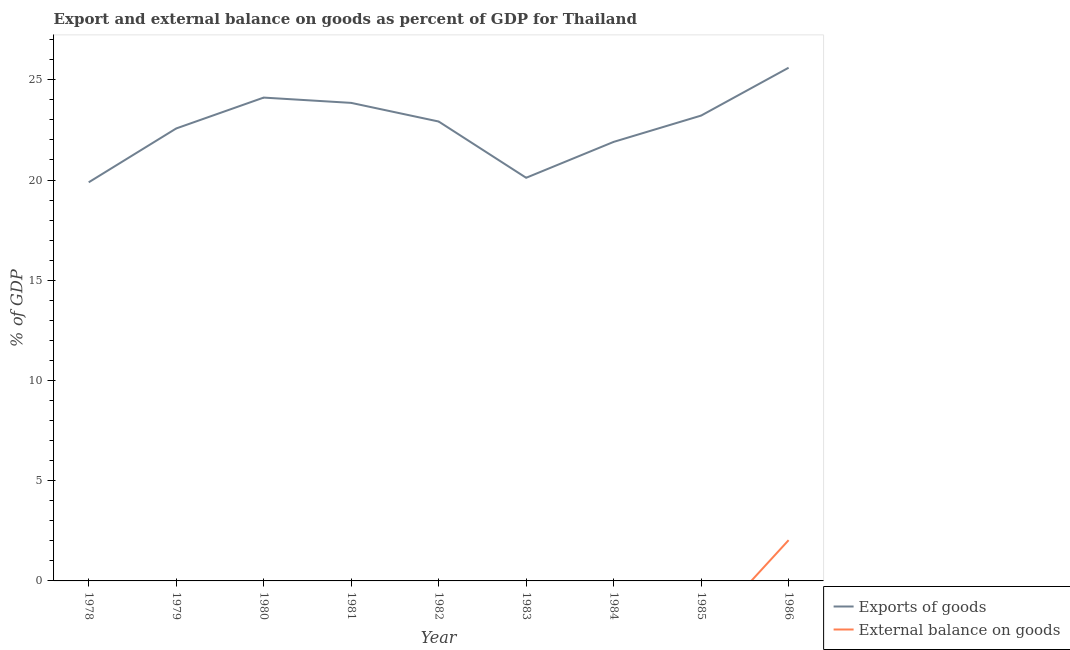How many different coloured lines are there?
Provide a succinct answer. 2. What is the export of goods as percentage of gdp in 1985?
Make the answer very short. 23.21. Across all years, what is the maximum external balance on goods as percentage of gdp?
Your answer should be compact. 2.03. Across all years, what is the minimum export of goods as percentage of gdp?
Give a very brief answer. 19.89. What is the total export of goods as percentage of gdp in the graph?
Ensure brevity in your answer.  204.16. What is the difference between the export of goods as percentage of gdp in 1980 and that in 1986?
Your answer should be compact. -1.49. What is the difference between the external balance on goods as percentage of gdp in 1980 and the export of goods as percentage of gdp in 1979?
Ensure brevity in your answer.  -22.57. What is the average external balance on goods as percentage of gdp per year?
Your response must be concise. 0.23. In the year 1986, what is the difference between the export of goods as percentage of gdp and external balance on goods as percentage of gdp?
Provide a succinct answer. 23.57. What is the ratio of the export of goods as percentage of gdp in 1982 to that in 1985?
Give a very brief answer. 0.99. Is the export of goods as percentage of gdp in 1984 less than that in 1985?
Provide a short and direct response. Yes. What is the difference between the highest and the second highest export of goods as percentage of gdp?
Make the answer very short. 1.49. What is the difference between the highest and the lowest export of goods as percentage of gdp?
Keep it short and to the point. 5.72. In how many years, is the export of goods as percentage of gdp greater than the average export of goods as percentage of gdp taken over all years?
Offer a terse response. 5. Is the sum of the export of goods as percentage of gdp in 1979 and 1986 greater than the maximum external balance on goods as percentage of gdp across all years?
Your answer should be very brief. Yes. Does the external balance on goods as percentage of gdp monotonically increase over the years?
Provide a short and direct response. No. Is the external balance on goods as percentage of gdp strictly greater than the export of goods as percentage of gdp over the years?
Provide a short and direct response. No. Is the external balance on goods as percentage of gdp strictly less than the export of goods as percentage of gdp over the years?
Give a very brief answer. Yes. Does the graph contain grids?
Offer a terse response. No. How many legend labels are there?
Keep it short and to the point. 2. What is the title of the graph?
Your answer should be very brief. Export and external balance on goods as percent of GDP for Thailand. What is the label or title of the Y-axis?
Offer a very short reply. % of GDP. What is the % of GDP in Exports of goods in 1978?
Provide a short and direct response. 19.89. What is the % of GDP in Exports of goods in 1979?
Your answer should be very brief. 22.57. What is the % of GDP in Exports of goods in 1980?
Make the answer very short. 24.11. What is the % of GDP of External balance on goods in 1980?
Offer a very short reply. 0. What is the % of GDP in Exports of goods in 1981?
Your answer should be compact. 23.85. What is the % of GDP in Exports of goods in 1982?
Offer a very short reply. 22.92. What is the % of GDP of External balance on goods in 1982?
Your answer should be compact. 0. What is the % of GDP of Exports of goods in 1983?
Ensure brevity in your answer.  20.11. What is the % of GDP in External balance on goods in 1983?
Give a very brief answer. 0. What is the % of GDP of Exports of goods in 1984?
Provide a succinct answer. 21.9. What is the % of GDP of External balance on goods in 1984?
Keep it short and to the point. 0. What is the % of GDP of Exports of goods in 1985?
Provide a succinct answer. 23.21. What is the % of GDP in Exports of goods in 1986?
Offer a very short reply. 25.6. What is the % of GDP in External balance on goods in 1986?
Offer a very short reply. 2.03. Across all years, what is the maximum % of GDP in Exports of goods?
Your response must be concise. 25.6. Across all years, what is the maximum % of GDP in External balance on goods?
Provide a short and direct response. 2.03. Across all years, what is the minimum % of GDP of Exports of goods?
Ensure brevity in your answer.  19.89. Across all years, what is the minimum % of GDP in External balance on goods?
Offer a terse response. 0. What is the total % of GDP of Exports of goods in the graph?
Provide a short and direct response. 204.16. What is the total % of GDP of External balance on goods in the graph?
Make the answer very short. 2.03. What is the difference between the % of GDP of Exports of goods in 1978 and that in 1979?
Your answer should be very brief. -2.69. What is the difference between the % of GDP of Exports of goods in 1978 and that in 1980?
Provide a succinct answer. -4.23. What is the difference between the % of GDP of Exports of goods in 1978 and that in 1981?
Provide a short and direct response. -3.96. What is the difference between the % of GDP of Exports of goods in 1978 and that in 1982?
Offer a terse response. -3.03. What is the difference between the % of GDP in Exports of goods in 1978 and that in 1983?
Provide a short and direct response. -0.23. What is the difference between the % of GDP of Exports of goods in 1978 and that in 1984?
Offer a terse response. -2.02. What is the difference between the % of GDP in Exports of goods in 1978 and that in 1985?
Ensure brevity in your answer.  -3.33. What is the difference between the % of GDP in Exports of goods in 1978 and that in 1986?
Provide a short and direct response. -5.72. What is the difference between the % of GDP in Exports of goods in 1979 and that in 1980?
Give a very brief answer. -1.54. What is the difference between the % of GDP in Exports of goods in 1979 and that in 1981?
Give a very brief answer. -1.28. What is the difference between the % of GDP in Exports of goods in 1979 and that in 1982?
Give a very brief answer. -0.35. What is the difference between the % of GDP of Exports of goods in 1979 and that in 1983?
Ensure brevity in your answer.  2.46. What is the difference between the % of GDP in Exports of goods in 1979 and that in 1984?
Provide a short and direct response. 0.67. What is the difference between the % of GDP of Exports of goods in 1979 and that in 1985?
Your response must be concise. -0.64. What is the difference between the % of GDP of Exports of goods in 1979 and that in 1986?
Provide a succinct answer. -3.03. What is the difference between the % of GDP in Exports of goods in 1980 and that in 1981?
Your answer should be very brief. 0.26. What is the difference between the % of GDP of Exports of goods in 1980 and that in 1982?
Give a very brief answer. 1.19. What is the difference between the % of GDP of Exports of goods in 1980 and that in 1983?
Offer a very short reply. 4. What is the difference between the % of GDP in Exports of goods in 1980 and that in 1984?
Keep it short and to the point. 2.21. What is the difference between the % of GDP of Exports of goods in 1980 and that in 1985?
Your answer should be very brief. 0.9. What is the difference between the % of GDP of Exports of goods in 1980 and that in 1986?
Provide a succinct answer. -1.49. What is the difference between the % of GDP in Exports of goods in 1981 and that in 1982?
Provide a succinct answer. 0.93. What is the difference between the % of GDP in Exports of goods in 1981 and that in 1983?
Offer a terse response. 3.74. What is the difference between the % of GDP in Exports of goods in 1981 and that in 1984?
Make the answer very short. 1.95. What is the difference between the % of GDP of Exports of goods in 1981 and that in 1985?
Your answer should be compact. 0.63. What is the difference between the % of GDP in Exports of goods in 1981 and that in 1986?
Provide a short and direct response. -1.75. What is the difference between the % of GDP of Exports of goods in 1982 and that in 1983?
Your answer should be compact. 2.81. What is the difference between the % of GDP in Exports of goods in 1982 and that in 1984?
Provide a short and direct response. 1.02. What is the difference between the % of GDP in Exports of goods in 1982 and that in 1985?
Give a very brief answer. -0.3. What is the difference between the % of GDP in Exports of goods in 1982 and that in 1986?
Your answer should be compact. -2.68. What is the difference between the % of GDP in Exports of goods in 1983 and that in 1984?
Ensure brevity in your answer.  -1.79. What is the difference between the % of GDP in Exports of goods in 1983 and that in 1985?
Offer a very short reply. -3.1. What is the difference between the % of GDP of Exports of goods in 1983 and that in 1986?
Keep it short and to the point. -5.49. What is the difference between the % of GDP in Exports of goods in 1984 and that in 1985?
Offer a very short reply. -1.31. What is the difference between the % of GDP in Exports of goods in 1984 and that in 1986?
Ensure brevity in your answer.  -3.7. What is the difference between the % of GDP in Exports of goods in 1985 and that in 1986?
Offer a terse response. -2.39. What is the difference between the % of GDP of Exports of goods in 1978 and the % of GDP of External balance on goods in 1986?
Your answer should be very brief. 17.85. What is the difference between the % of GDP of Exports of goods in 1979 and the % of GDP of External balance on goods in 1986?
Make the answer very short. 20.54. What is the difference between the % of GDP in Exports of goods in 1980 and the % of GDP in External balance on goods in 1986?
Provide a short and direct response. 22.08. What is the difference between the % of GDP in Exports of goods in 1981 and the % of GDP in External balance on goods in 1986?
Your answer should be compact. 21.81. What is the difference between the % of GDP in Exports of goods in 1982 and the % of GDP in External balance on goods in 1986?
Offer a terse response. 20.89. What is the difference between the % of GDP of Exports of goods in 1983 and the % of GDP of External balance on goods in 1986?
Provide a short and direct response. 18.08. What is the difference between the % of GDP of Exports of goods in 1984 and the % of GDP of External balance on goods in 1986?
Offer a terse response. 19.87. What is the difference between the % of GDP in Exports of goods in 1985 and the % of GDP in External balance on goods in 1986?
Your answer should be very brief. 21.18. What is the average % of GDP of Exports of goods per year?
Make the answer very short. 22.68. What is the average % of GDP in External balance on goods per year?
Ensure brevity in your answer.  0.23. In the year 1986, what is the difference between the % of GDP of Exports of goods and % of GDP of External balance on goods?
Keep it short and to the point. 23.57. What is the ratio of the % of GDP of Exports of goods in 1978 to that in 1979?
Your answer should be compact. 0.88. What is the ratio of the % of GDP of Exports of goods in 1978 to that in 1980?
Keep it short and to the point. 0.82. What is the ratio of the % of GDP in Exports of goods in 1978 to that in 1981?
Give a very brief answer. 0.83. What is the ratio of the % of GDP in Exports of goods in 1978 to that in 1982?
Give a very brief answer. 0.87. What is the ratio of the % of GDP of Exports of goods in 1978 to that in 1984?
Offer a terse response. 0.91. What is the ratio of the % of GDP of Exports of goods in 1978 to that in 1985?
Keep it short and to the point. 0.86. What is the ratio of the % of GDP of Exports of goods in 1978 to that in 1986?
Keep it short and to the point. 0.78. What is the ratio of the % of GDP in Exports of goods in 1979 to that in 1980?
Ensure brevity in your answer.  0.94. What is the ratio of the % of GDP of Exports of goods in 1979 to that in 1981?
Your answer should be compact. 0.95. What is the ratio of the % of GDP of Exports of goods in 1979 to that in 1982?
Offer a very short reply. 0.98. What is the ratio of the % of GDP in Exports of goods in 1979 to that in 1983?
Keep it short and to the point. 1.12. What is the ratio of the % of GDP of Exports of goods in 1979 to that in 1984?
Offer a terse response. 1.03. What is the ratio of the % of GDP of Exports of goods in 1979 to that in 1985?
Ensure brevity in your answer.  0.97. What is the ratio of the % of GDP of Exports of goods in 1979 to that in 1986?
Your response must be concise. 0.88. What is the ratio of the % of GDP of Exports of goods in 1980 to that in 1981?
Keep it short and to the point. 1.01. What is the ratio of the % of GDP of Exports of goods in 1980 to that in 1982?
Your response must be concise. 1.05. What is the ratio of the % of GDP of Exports of goods in 1980 to that in 1983?
Provide a succinct answer. 1.2. What is the ratio of the % of GDP of Exports of goods in 1980 to that in 1984?
Provide a short and direct response. 1.1. What is the ratio of the % of GDP in Exports of goods in 1980 to that in 1985?
Make the answer very short. 1.04. What is the ratio of the % of GDP in Exports of goods in 1980 to that in 1986?
Provide a succinct answer. 0.94. What is the ratio of the % of GDP in Exports of goods in 1981 to that in 1982?
Ensure brevity in your answer.  1.04. What is the ratio of the % of GDP in Exports of goods in 1981 to that in 1983?
Keep it short and to the point. 1.19. What is the ratio of the % of GDP in Exports of goods in 1981 to that in 1984?
Provide a short and direct response. 1.09. What is the ratio of the % of GDP in Exports of goods in 1981 to that in 1985?
Offer a terse response. 1.03. What is the ratio of the % of GDP in Exports of goods in 1981 to that in 1986?
Offer a terse response. 0.93. What is the ratio of the % of GDP of Exports of goods in 1982 to that in 1983?
Offer a terse response. 1.14. What is the ratio of the % of GDP of Exports of goods in 1982 to that in 1984?
Provide a short and direct response. 1.05. What is the ratio of the % of GDP of Exports of goods in 1982 to that in 1985?
Provide a short and direct response. 0.99. What is the ratio of the % of GDP of Exports of goods in 1982 to that in 1986?
Offer a very short reply. 0.9. What is the ratio of the % of GDP of Exports of goods in 1983 to that in 1984?
Provide a succinct answer. 0.92. What is the ratio of the % of GDP of Exports of goods in 1983 to that in 1985?
Keep it short and to the point. 0.87. What is the ratio of the % of GDP in Exports of goods in 1983 to that in 1986?
Your answer should be compact. 0.79. What is the ratio of the % of GDP of Exports of goods in 1984 to that in 1985?
Ensure brevity in your answer.  0.94. What is the ratio of the % of GDP in Exports of goods in 1984 to that in 1986?
Offer a terse response. 0.86. What is the ratio of the % of GDP of Exports of goods in 1985 to that in 1986?
Your response must be concise. 0.91. What is the difference between the highest and the second highest % of GDP in Exports of goods?
Your response must be concise. 1.49. What is the difference between the highest and the lowest % of GDP of Exports of goods?
Offer a very short reply. 5.72. What is the difference between the highest and the lowest % of GDP in External balance on goods?
Your answer should be compact. 2.03. 